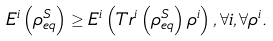<formula> <loc_0><loc_0><loc_500><loc_500>E ^ { i } \left ( \rho ^ { S } _ { e q } \right ) \geq E ^ { i } \left ( T r ^ { i } \left ( \rho ^ { S } _ { e q } \right ) \rho ^ { i } \right ) , \forall i , \forall \rho ^ { i } .</formula> 